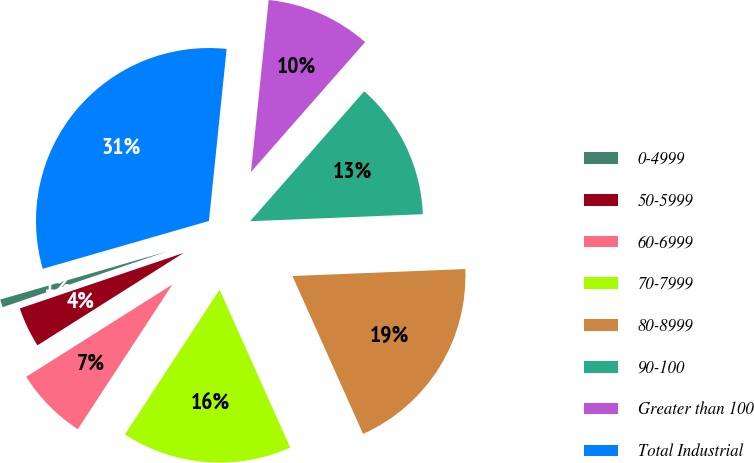Convert chart to OTSL. <chart><loc_0><loc_0><loc_500><loc_500><pie_chart><fcel>0-4999<fcel>50-5999<fcel>60-6999<fcel>70-7999<fcel>80-8999<fcel>90-100<fcel>Greater than 100<fcel>Total Industrial<nl><fcel>0.74%<fcel>3.77%<fcel>6.81%<fcel>15.91%<fcel>18.95%<fcel>12.88%<fcel>9.84%<fcel>31.09%<nl></chart> 